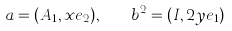Convert formula to latex. <formula><loc_0><loc_0><loc_500><loc_500>a = ( A _ { 1 } , x e _ { 2 } ) , \quad b ^ { 2 } = ( I , 2 y e _ { 1 } )</formula> 